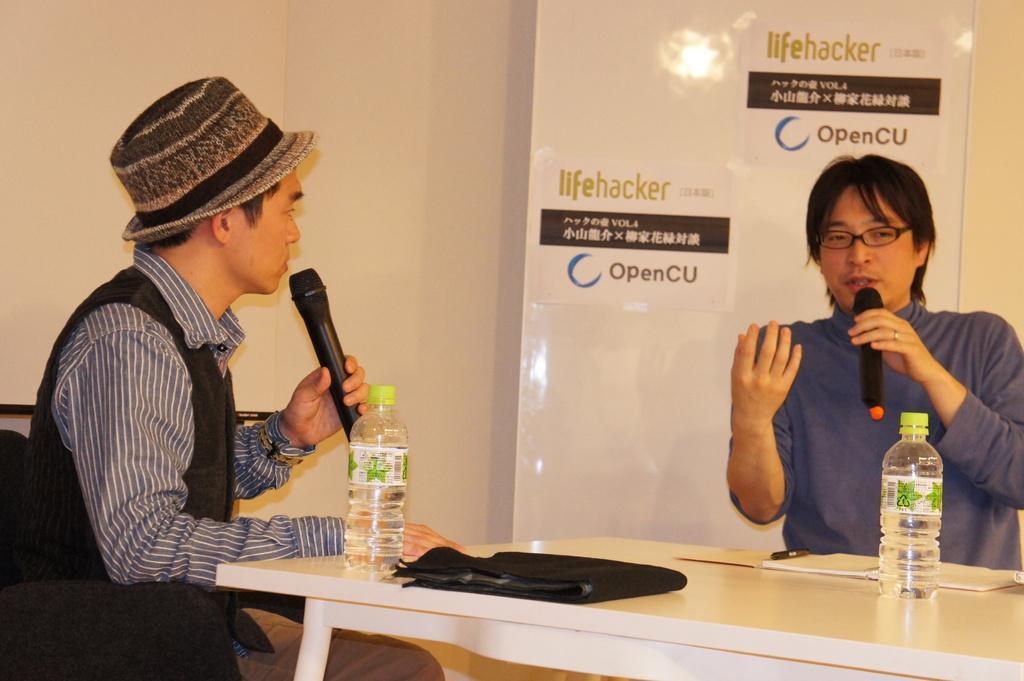In one or two sentences, can you explain what this image depicts? As we can see in the image there is a white color wall, banner, two people sitting on chairs and holding mics. There is a table. On table there are bottles and As we can see in the image there papers. 